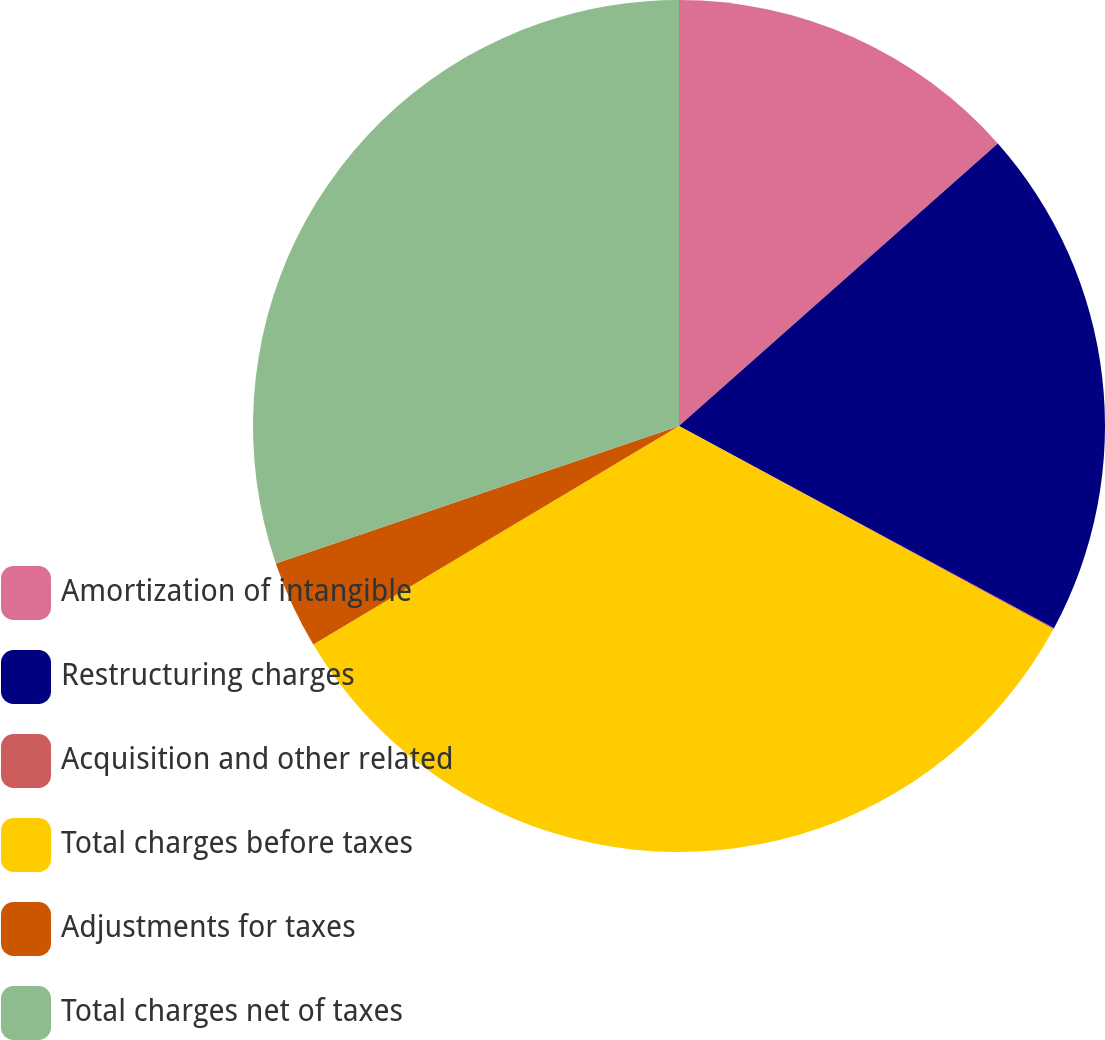Convert chart to OTSL. <chart><loc_0><loc_0><loc_500><loc_500><pie_chart><fcel>Amortization of intangible<fcel>Restructuring charges<fcel>Acquisition and other related<fcel>Total charges before taxes<fcel>Adjustments for taxes<fcel>Total charges net of taxes<nl><fcel>13.46%<fcel>19.41%<fcel>0.05%<fcel>33.51%<fcel>3.34%<fcel>30.23%<nl></chart> 